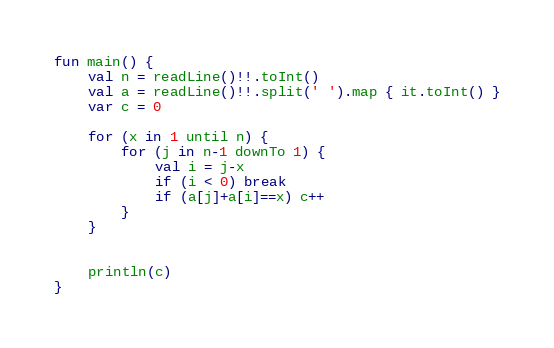<code> <loc_0><loc_0><loc_500><loc_500><_Kotlin_>fun main() {
    val n = readLine()!!.toInt()
    val a = readLine()!!.split(' ').map { it.toInt() }
    var c = 0

    for (x in 1 until n) {
        for (j in n-1 downTo 1) {
            val i = j-x
            if (i < 0) break
            if (a[j]+a[i]==x) c++
        }
    }


    println(c)
}

</code> 